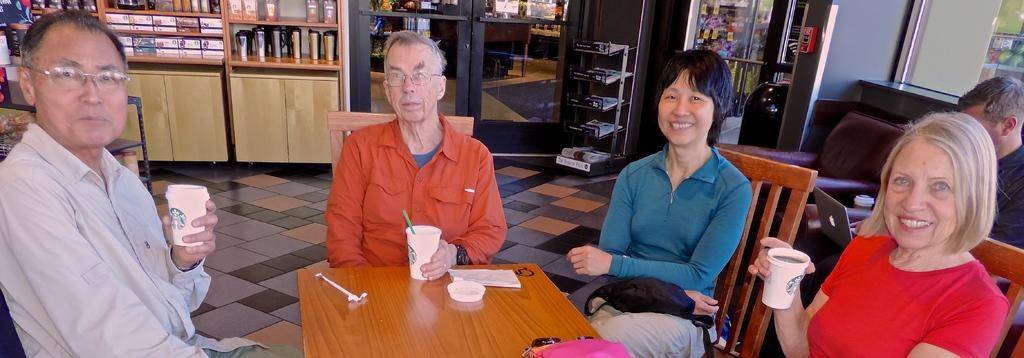How many people are present in the image? There are four people in the image, two men and two women. What are the individuals doing in the image? All four individuals are sitting on chairs. What are they holding in their hands? Each person is holding a cup. Can you describe the background of the image? There are bottles visible in the background. Are there any other people in the background? Yes, there is one more person in the background. What type of soap is being used in the image? There is no soap present in the image. 